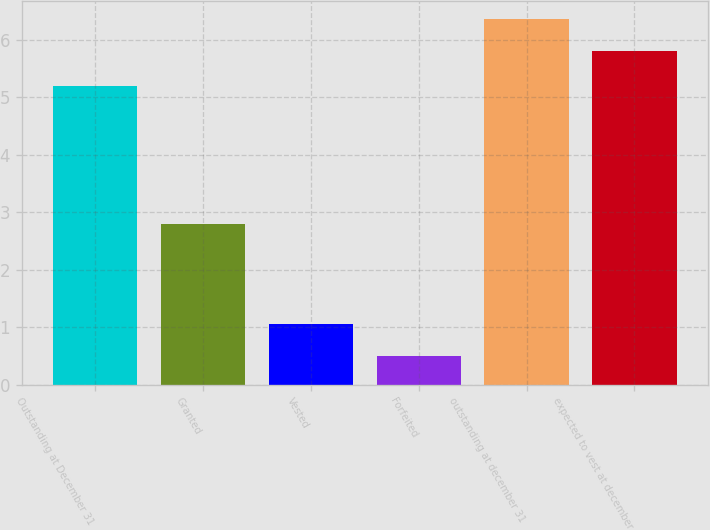Convert chart to OTSL. <chart><loc_0><loc_0><loc_500><loc_500><bar_chart><fcel>Outstanding at December 31<fcel>Granted<fcel>Vested<fcel>Forfeited<fcel>outstanding at december 31<fcel>expected to vest at december<nl><fcel>5.2<fcel>2.8<fcel>1.06<fcel>0.5<fcel>6.36<fcel>5.8<nl></chart> 